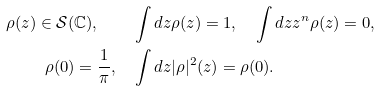Convert formula to latex. <formula><loc_0><loc_0><loc_500><loc_500>\rho ( z ) \in \mathcal { S } ( \mathbb { C } ) , \quad & \int d z \rho ( z ) = 1 , \quad \int d z z ^ { n } \rho ( z ) = 0 , \\ \rho ( 0 ) = \frac { 1 } { \pi } , \quad & \int d z | \rho | ^ { 2 } ( z ) = \rho ( 0 ) .</formula> 